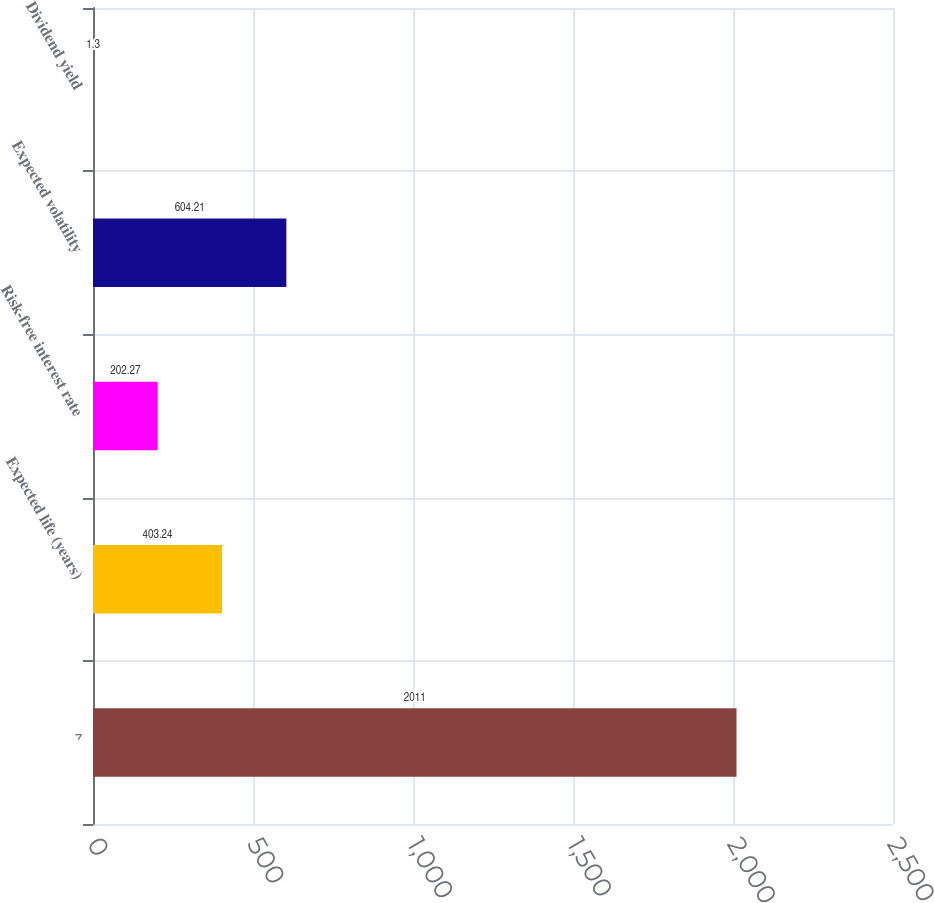Convert chart to OTSL. <chart><loc_0><loc_0><loc_500><loc_500><bar_chart><fcel>^<fcel>Expected life (years)<fcel>Risk-free interest rate<fcel>Expected volatility<fcel>Dividend yield<nl><fcel>2011<fcel>403.24<fcel>202.27<fcel>604.21<fcel>1.3<nl></chart> 